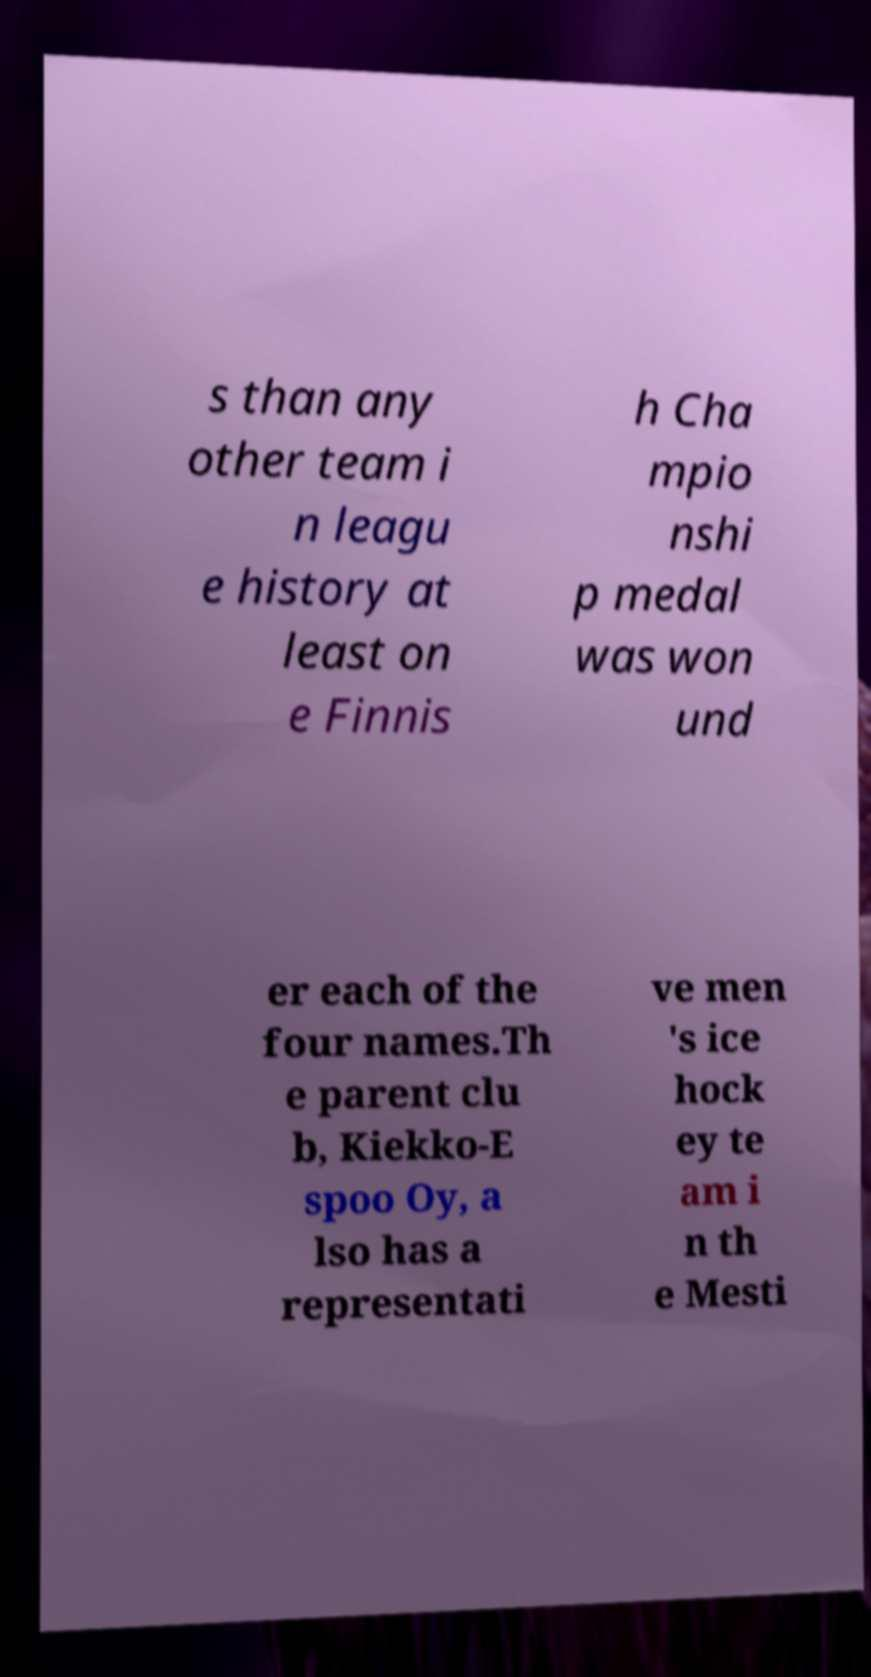Could you extract and type out the text from this image? s than any other team i n leagu e history at least on e Finnis h Cha mpio nshi p medal was won und er each of the four names.Th e parent clu b, Kiekko-E spoo Oy, a lso has a representati ve men 's ice hock ey te am i n th e Mesti 